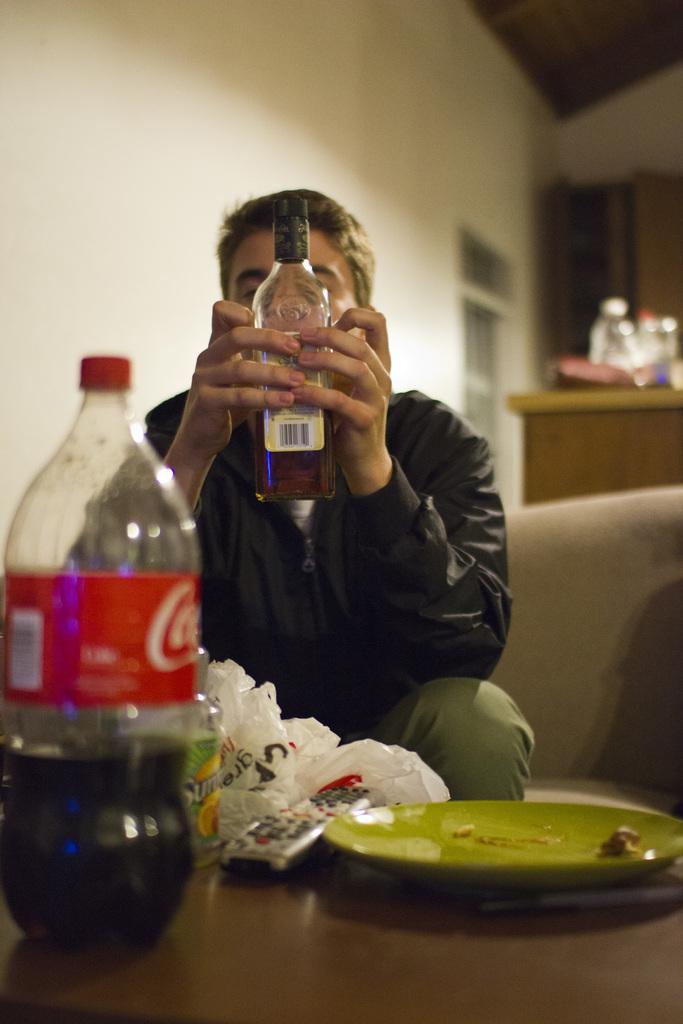Who is present in the image? There is a man in the image. What is the man holding in the image? The man is holding a bottle. Are there any other bottles visible in the image? Yes, there is another bottle in the image. What other objects can be seen in the image? There is a remote and a plate in the image. What type of pin can be seen holding the man's shirt in the image? There is no pin visible in the image; the man's shirt is not being held by a pin. 